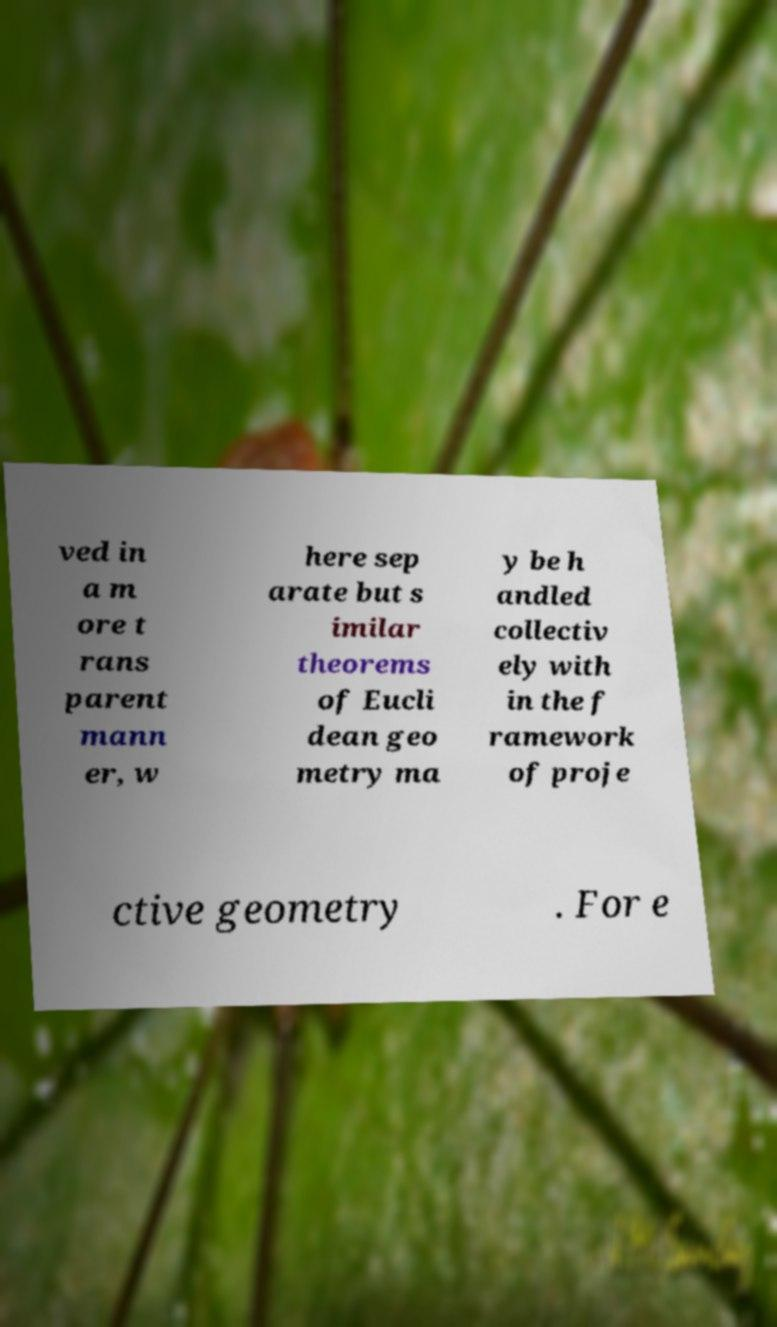For documentation purposes, I need the text within this image transcribed. Could you provide that? ved in a m ore t rans parent mann er, w here sep arate but s imilar theorems of Eucli dean geo metry ma y be h andled collectiv ely with in the f ramework of proje ctive geometry . For e 